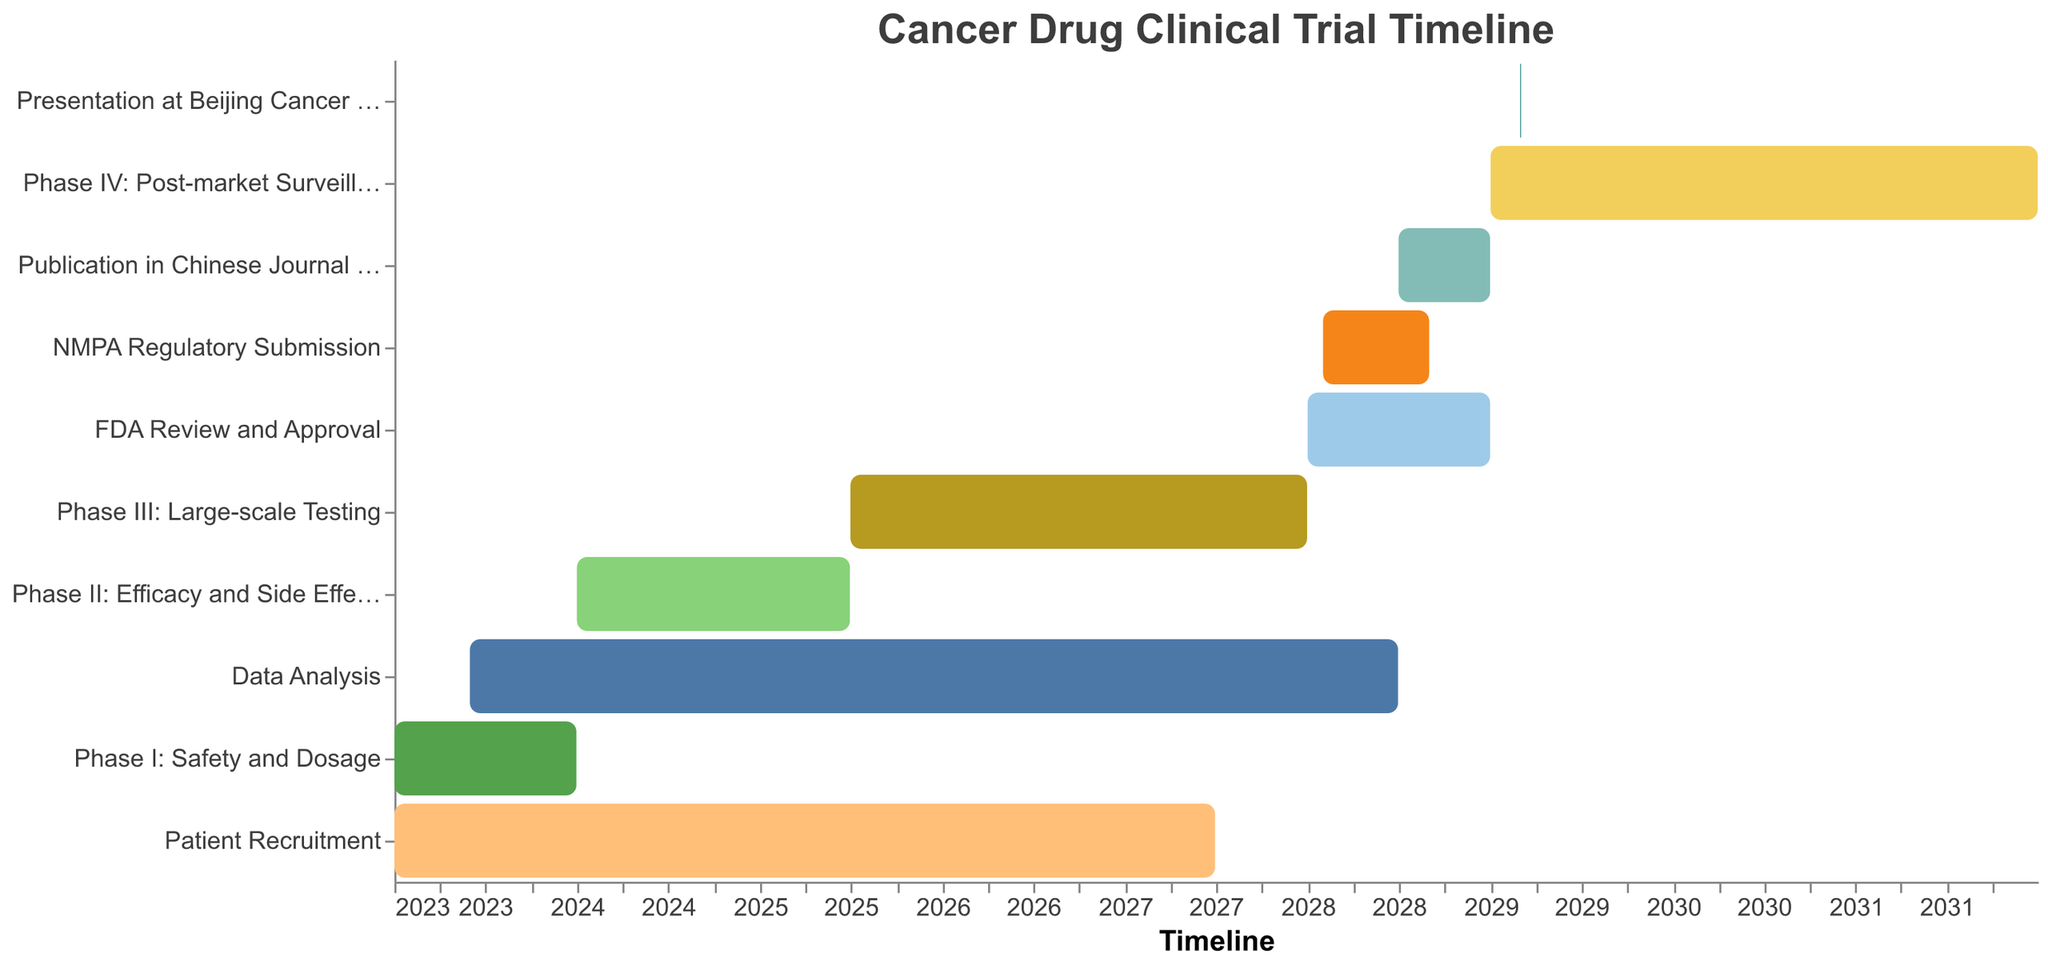What is the title of the figure? The title of the figure is usually displayed prominently at the top. In this figure, it is shown in large font size.
Answer: Cancer Drug Clinical Trial Timeline Which task has the longest duration? To find the task with the longest duration, examine the start and end dates of all tasks and calculate the length of each task's bar. The length from January 1, 2029, to December 31, 2031, is the longest.
Answer: Phase IV: Post-market Surveillance How many phases are there in the clinical trial process? Count the number of tasks that specifically state "Phase I", "Phase II", "Phase III", and "Phase IV".
Answer: 4 Between which years does Phase III: Large-scale Testing occur? By observing the timeline axis corresponding to the task "Phase III: Large-scale Testing," note the start and end dates.
Answer: 2025 to 2027 How much time does FDA Review and Approval take? Determine the start and end dates of "FDA Review and Approval" and calculate the difference.
Answer: 1 year Which two tasks overlap during 2028? Identify tasks that begin before or in 2028 and end after the start of 2028.
Answer: FDA Review and Approval, Data Analysis, NMPA Regulatory Submission Compare the duration between Phase I and Phase II. Which is longer? Calculate the duration of both phases by subtracting the start date from the end date for each phase.
Answer: Phase II What is the total duration from the start of Phase I to the end of Phase III? Sum the durations of Phase I, Phase II, and Phase III by computing the difference between each phase's start and end dates, then adding these durations together.
Answer: 5.5 years During which phase does Presentation at Beijing Cancer Symposium occur? Identify which phase(s) include the year 2029, as the symposium occurs from March 1-3, 2029.
Answer: Phase IV: Post-market Surveillance Calculate the time span from the start of Patient Recruitment to the end of Publicaion in Chinese Journal of Cancer. Determine the start date of Patient Recruitment and the end date of Publication in Chinese Journal of Cancer, then find the difference between these dates.
Answer: 5.5 years 